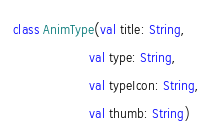Convert code to text. <code><loc_0><loc_0><loc_500><loc_500><_Kotlin_>class AnimType(val title: String,
                    val type: String,
                    val typeIcon: String,
                    val thumb: String)</code> 